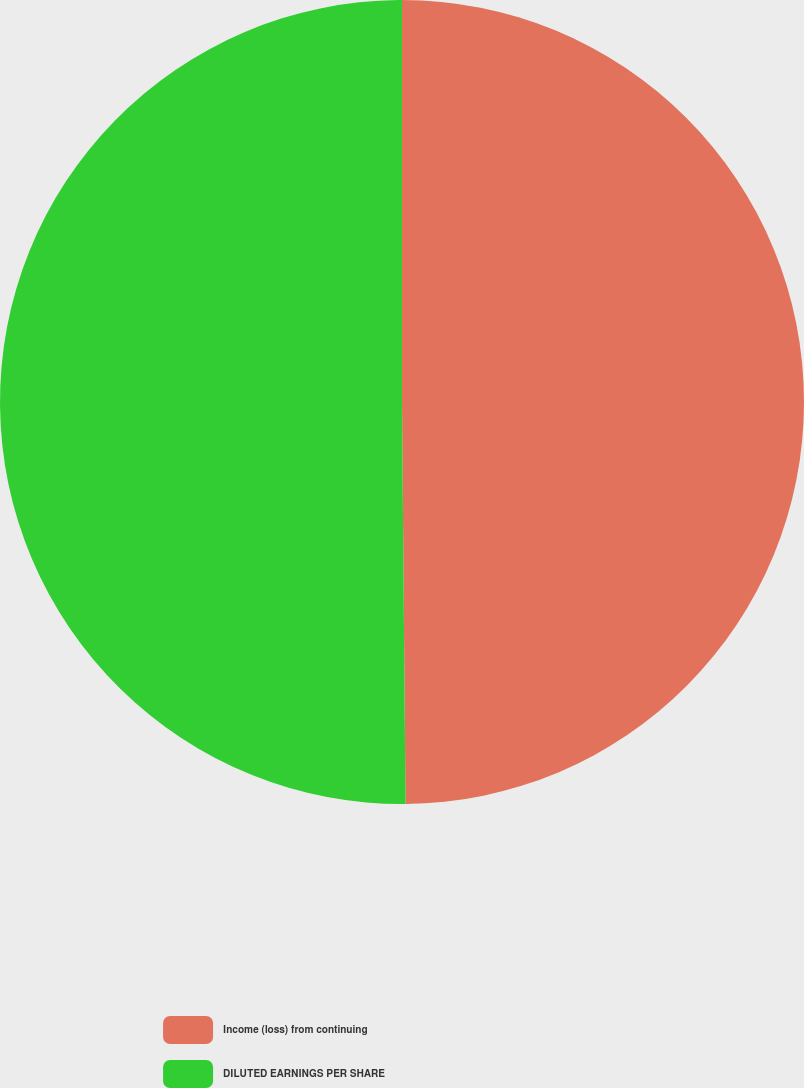Convert chart. <chart><loc_0><loc_0><loc_500><loc_500><pie_chart><fcel>Income (loss) from continuing<fcel>DILUTED EARNINGS PER SHARE<nl><fcel>49.86%<fcel>50.14%<nl></chart> 